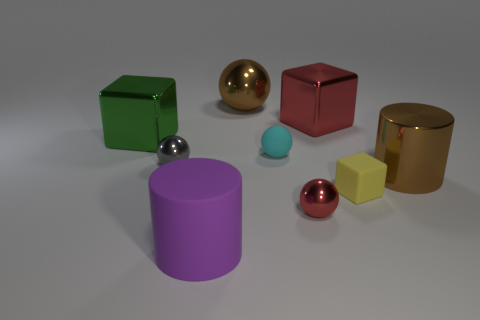How many other things are there of the same shape as the tiny red object?
Provide a short and direct response. 3. Is there anything else that is the same color as the big rubber cylinder?
Your answer should be very brief. No. Is the color of the large metallic ball the same as the small sphere to the left of the cyan thing?
Offer a very short reply. No. What number of other things are the same size as the brown metal cylinder?
Provide a succinct answer. 4. There is a shiny ball that is the same color as the big metal cylinder; what size is it?
Give a very brief answer. Large. How many spheres are either small purple rubber objects or small red metal objects?
Ensure brevity in your answer.  1. There is a big metallic object on the left side of the purple cylinder; is it the same shape as the large purple thing?
Offer a terse response. No. Are there more large purple cylinders in front of the big purple matte cylinder than tiny blue shiny blocks?
Keep it short and to the point. No. There is another cylinder that is the same size as the rubber cylinder; what color is it?
Give a very brief answer. Brown. How many things are either red metallic objects that are in front of the big brown metallic cylinder or big green blocks?
Offer a terse response. 2. 